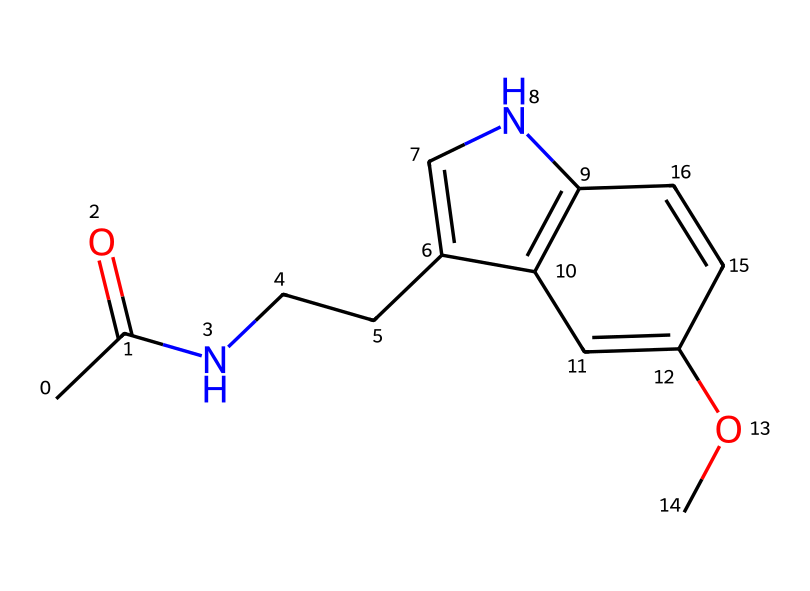What is the molecular formula of melatonin? To determine the molecular formula, we can parse the SMILES representation for each type of atom present. The atoms observed are carbon (C), hydrogen (H), oxygen (O), and nitrogen (N). From the structure, we find a total of 13 carbons, 16 hydrogens, 2 nitrogens, and 1 oxygen. Thus, the molecular formula is C13H16N2O.
Answer: C13H16N2O How many rings are in the structure of melatonin? By examining the SMILES representation, we can identify the points where rings are formed, denoted by the numbers in the sequence. In this case, we find two ring structures within the molecule. One connects atoms marked with the number '1', and another connects those marked with the number '2'. Therefore, there are two rings.
Answer: 2 What type of functional group is present in melatonin? In the SMILES structure, the presence of a carbonyl group (C=O) indicates the molecule has a ketone functional group. Additionally, the amine component (NH) suggests there is an amine functional group as well. However, the prominent functional group with a direct impact on its health effects is the amine group.
Answer: amine How many nitrogen atoms are in melatonin? The SMILES string contains two nitrogen atoms, clearly indicated in its structure. Each nitrogen atom can be counted directly from the visual representation.
Answer: 2 What other element is directly bonded to the nitrogen in melatonin? Looking at the SMILES, we can identify that the nitrogen atoms are bonded to carbon atoms within the molecular structure. More specifically, one nitrogen is connected to a carbon chain (CCC), which suggests it is bound to the structure at various points.
Answer: carbon 